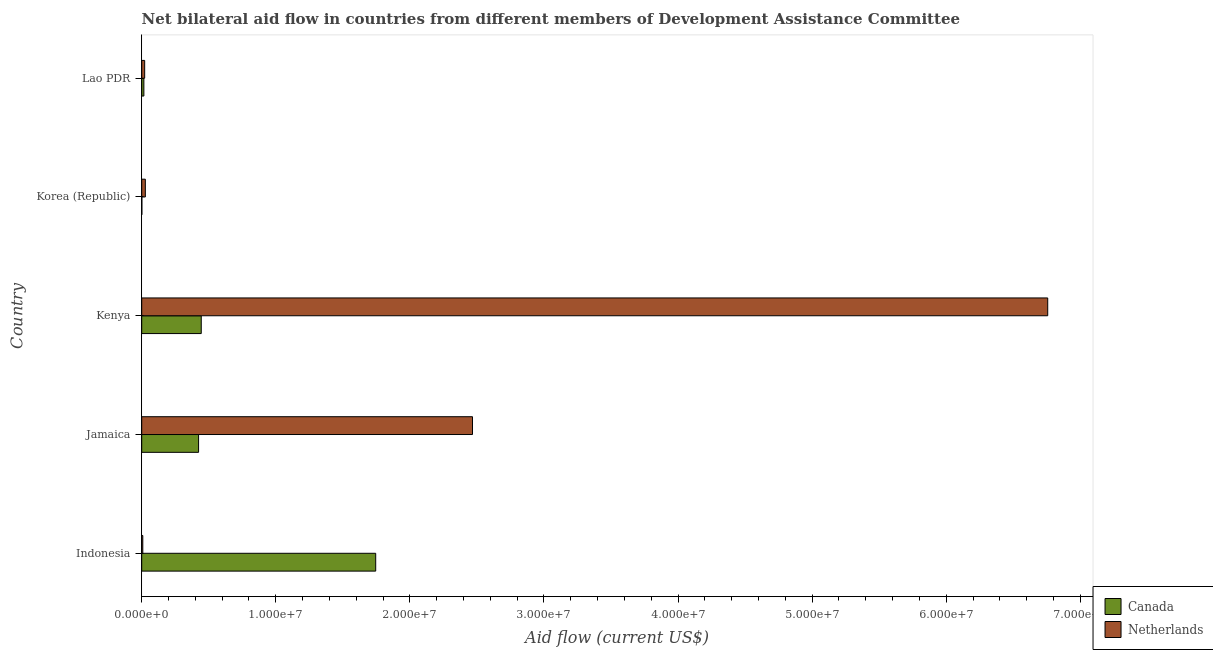How many bars are there on the 1st tick from the bottom?
Offer a terse response. 2. What is the label of the 5th group of bars from the top?
Offer a very short reply. Indonesia. In how many cases, is the number of bars for a given country not equal to the number of legend labels?
Your answer should be very brief. 0. What is the amount of aid given by canada in Kenya?
Offer a very short reply. 4.44e+06. Across all countries, what is the maximum amount of aid given by netherlands?
Keep it short and to the point. 6.76e+07. Across all countries, what is the minimum amount of aid given by canada?
Give a very brief answer. 10000. What is the total amount of aid given by netherlands in the graph?
Make the answer very short. 9.28e+07. What is the difference between the amount of aid given by netherlands in Jamaica and that in Lao PDR?
Give a very brief answer. 2.44e+07. What is the difference between the amount of aid given by netherlands in Kenya and the amount of aid given by canada in Indonesia?
Provide a succinct answer. 5.01e+07. What is the average amount of aid given by canada per country?
Keep it short and to the point. 5.26e+06. What is the difference between the amount of aid given by canada and amount of aid given by netherlands in Korea (Republic)?
Provide a succinct answer. -2.60e+05. What is the ratio of the amount of aid given by canada in Jamaica to that in Kenya?
Make the answer very short. 0.95. Is the amount of aid given by netherlands in Kenya less than that in Lao PDR?
Give a very brief answer. No. Is the difference between the amount of aid given by netherlands in Kenya and Korea (Republic) greater than the difference between the amount of aid given by canada in Kenya and Korea (Republic)?
Offer a terse response. Yes. What is the difference between the highest and the second highest amount of aid given by netherlands?
Ensure brevity in your answer.  4.29e+07. What is the difference between the highest and the lowest amount of aid given by netherlands?
Keep it short and to the point. 6.75e+07. Is the sum of the amount of aid given by netherlands in Indonesia and Lao PDR greater than the maximum amount of aid given by canada across all countries?
Keep it short and to the point. No. What does the 2nd bar from the top in Jamaica represents?
Offer a terse response. Canada. What does the 2nd bar from the bottom in Kenya represents?
Make the answer very short. Netherlands. How many bars are there?
Your response must be concise. 10. Are all the bars in the graph horizontal?
Offer a terse response. Yes. What is the difference between two consecutive major ticks on the X-axis?
Keep it short and to the point. 1.00e+07. Are the values on the major ticks of X-axis written in scientific E-notation?
Offer a terse response. Yes. Does the graph contain grids?
Offer a terse response. No. Where does the legend appear in the graph?
Keep it short and to the point. Bottom right. How many legend labels are there?
Keep it short and to the point. 2. How are the legend labels stacked?
Keep it short and to the point. Vertical. What is the title of the graph?
Make the answer very short. Net bilateral aid flow in countries from different members of Development Assistance Committee. Does "International Tourists" appear as one of the legend labels in the graph?
Your response must be concise. No. What is the label or title of the X-axis?
Your response must be concise. Aid flow (current US$). What is the Aid flow (current US$) in Canada in Indonesia?
Give a very brief answer. 1.74e+07. What is the Aid flow (current US$) in Netherlands in Indonesia?
Ensure brevity in your answer.  8.00e+04. What is the Aid flow (current US$) in Canada in Jamaica?
Ensure brevity in your answer.  4.24e+06. What is the Aid flow (current US$) in Netherlands in Jamaica?
Give a very brief answer. 2.47e+07. What is the Aid flow (current US$) in Canada in Kenya?
Offer a very short reply. 4.44e+06. What is the Aid flow (current US$) of Netherlands in Kenya?
Offer a terse response. 6.76e+07. What is the Aid flow (current US$) in Canada in Lao PDR?
Make the answer very short. 1.60e+05. Across all countries, what is the maximum Aid flow (current US$) in Canada?
Your answer should be compact. 1.74e+07. Across all countries, what is the maximum Aid flow (current US$) in Netherlands?
Provide a short and direct response. 6.76e+07. What is the total Aid flow (current US$) of Canada in the graph?
Your response must be concise. 2.63e+07. What is the total Aid flow (current US$) in Netherlands in the graph?
Offer a very short reply. 9.28e+07. What is the difference between the Aid flow (current US$) in Canada in Indonesia and that in Jamaica?
Ensure brevity in your answer.  1.32e+07. What is the difference between the Aid flow (current US$) in Netherlands in Indonesia and that in Jamaica?
Give a very brief answer. -2.46e+07. What is the difference between the Aid flow (current US$) of Canada in Indonesia and that in Kenya?
Make the answer very short. 1.30e+07. What is the difference between the Aid flow (current US$) of Netherlands in Indonesia and that in Kenya?
Offer a terse response. -6.75e+07. What is the difference between the Aid flow (current US$) in Canada in Indonesia and that in Korea (Republic)?
Provide a succinct answer. 1.74e+07. What is the difference between the Aid flow (current US$) of Netherlands in Indonesia and that in Korea (Republic)?
Your answer should be very brief. -1.90e+05. What is the difference between the Aid flow (current US$) in Canada in Indonesia and that in Lao PDR?
Ensure brevity in your answer.  1.73e+07. What is the difference between the Aid flow (current US$) of Netherlands in Indonesia and that in Lao PDR?
Ensure brevity in your answer.  -1.40e+05. What is the difference between the Aid flow (current US$) of Netherlands in Jamaica and that in Kenya?
Your answer should be very brief. -4.29e+07. What is the difference between the Aid flow (current US$) of Canada in Jamaica and that in Korea (Republic)?
Offer a very short reply. 4.23e+06. What is the difference between the Aid flow (current US$) in Netherlands in Jamaica and that in Korea (Republic)?
Your answer should be very brief. 2.44e+07. What is the difference between the Aid flow (current US$) of Canada in Jamaica and that in Lao PDR?
Your response must be concise. 4.08e+06. What is the difference between the Aid flow (current US$) of Netherlands in Jamaica and that in Lao PDR?
Make the answer very short. 2.44e+07. What is the difference between the Aid flow (current US$) in Canada in Kenya and that in Korea (Republic)?
Offer a terse response. 4.43e+06. What is the difference between the Aid flow (current US$) in Netherlands in Kenya and that in Korea (Republic)?
Your response must be concise. 6.73e+07. What is the difference between the Aid flow (current US$) in Canada in Kenya and that in Lao PDR?
Offer a terse response. 4.28e+06. What is the difference between the Aid flow (current US$) of Netherlands in Kenya and that in Lao PDR?
Offer a terse response. 6.74e+07. What is the difference between the Aid flow (current US$) of Canada in Korea (Republic) and that in Lao PDR?
Your answer should be very brief. -1.50e+05. What is the difference between the Aid flow (current US$) in Canada in Indonesia and the Aid flow (current US$) in Netherlands in Jamaica?
Provide a succinct answer. -7.22e+06. What is the difference between the Aid flow (current US$) in Canada in Indonesia and the Aid flow (current US$) in Netherlands in Kenya?
Provide a short and direct response. -5.01e+07. What is the difference between the Aid flow (current US$) of Canada in Indonesia and the Aid flow (current US$) of Netherlands in Korea (Republic)?
Provide a succinct answer. 1.72e+07. What is the difference between the Aid flow (current US$) of Canada in Indonesia and the Aid flow (current US$) of Netherlands in Lao PDR?
Ensure brevity in your answer.  1.72e+07. What is the difference between the Aid flow (current US$) of Canada in Jamaica and the Aid flow (current US$) of Netherlands in Kenya?
Provide a succinct answer. -6.33e+07. What is the difference between the Aid flow (current US$) in Canada in Jamaica and the Aid flow (current US$) in Netherlands in Korea (Republic)?
Provide a succinct answer. 3.97e+06. What is the difference between the Aid flow (current US$) of Canada in Jamaica and the Aid flow (current US$) of Netherlands in Lao PDR?
Your response must be concise. 4.02e+06. What is the difference between the Aid flow (current US$) in Canada in Kenya and the Aid flow (current US$) in Netherlands in Korea (Republic)?
Offer a terse response. 4.17e+06. What is the difference between the Aid flow (current US$) in Canada in Kenya and the Aid flow (current US$) in Netherlands in Lao PDR?
Keep it short and to the point. 4.22e+06. What is the difference between the Aid flow (current US$) of Canada in Korea (Republic) and the Aid flow (current US$) of Netherlands in Lao PDR?
Provide a short and direct response. -2.10e+05. What is the average Aid flow (current US$) in Canada per country?
Make the answer very short. 5.26e+06. What is the average Aid flow (current US$) of Netherlands per country?
Ensure brevity in your answer.  1.86e+07. What is the difference between the Aid flow (current US$) in Canada and Aid flow (current US$) in Netherlands in Indonesia?
Your response must be concise. 1.74e+07. What is the difference between the Aid flow (current US$) in Canada and Aid flow (current US$) in Netherlands in Jamaica?
Offer a very short reply. -2.04e+07. What is the difference between the Aid flow (current US$) of Canada and Aid flow (current US$) of Netherlands in Kenya?
Keep it short and to the point. -6.31e+07. What is the difference between the Aid flow (current US$) in Canada and Aid flow (current US$) in Netherlands in Korea (Republic)?
Ensure brevity in your answer.  -2.60e+05. What is the ratio of the Aid flow (current US$) in Canada in Indonesia to that in Jamaica?
Offer a terse response. 4.12. What is the ratio of the Aid flow (current US$) in Netherlands in Indonesia to that in Jamaica?
Offer a very short reply. 0. What is the ratio of the Aid flow (current US$) in Canada in Indonesia to that in Kenya?
Offer a terse response. 3.93. What is the ratio of the Aid flow (current US$) in Netherlands in Indonesia to that in Kenya?
Provide a succinct answer. 0. What is the ratio of the Aid flow (current US$) of Canada in Indonesia to that in Korea (Republic)?
Provide a short and direct response. 1745. What is the ratio of the Aid flow (current US$) of Netherlands in Indonesia to that in Korea (Republic)?
Keep it short and to the point. 0.3. What is the ratio of the Aid flow (current US$) in Canada in Indonesia to that in Lao PDR?
Make the answer very short. 109.06. What is the ratio of the Aid flow (current US$) in Netherlands in Indonesia to that in Lao PDR?
Your response must be concise. 0.36. What is the ratio of the Aid flow (current US$) of Canada in Jamaica to that in Kenya?
Your answer should be compact. 0.95. What is the ratio of the Aid flow (current US$) in Netherlands in Jamaica to that in Kenya?
Ensure brevity in your answer.  0.37. What is the ratio of the Aid flow (current US$) in Canada in Jamaica to that in Korea (Republic)?
Provide a short and direct response. 424. What is the ratio of the Aid flow (current US$) in Netherlands in Jamaica to that in Korea (Republic)?
Your answer should be very brief. 91.37. What is the ratio of the Aid flow (current US$) of Netherlands in Jamaica to that in Lao PDR?
Provide a short and direct response. 112.14. What is the ratio of the Aid flow (current US$) in Canada in Kenya to that in Korea (Republic)?
Give a very brief answer. 444. What is the ratio of the Aid flow (current US$) in Netherlands in Kenya to that in Korea (Republic)?
Your response must be concise. 250.26. What is the ratio of the Aid flow (current US$) of Canada in Kenya to that in Lao PDR?
Provide a short and direct response. 27.75. What is the ratio of the Aid flow (current US$) in Netherlands in Kenya to that in Lao PDR?
Provide a succinct answer. 307.14. What is the ratio of the Aid flow (current US$) of Canada in Korea (Republic) to that in Lao PDR?
Your answer should be very brief. 0.06. What is the ratio of the Aid flow (current US$) in Netherlands in Korea (Republic) to that in Lao PDR?
Offer a terse response. 1.23. What is the difference between the highest and the second highest Aid flow (current US$) in Canada?
Make the answer very short. 1.30e+07. What is the difference between the highest and the second highest Aid flow (current US$) of Netherlands?
Keep it short and to the point. 4.29e+07. What is the difference between the highest and the lowest Aid flow (current US$) in Canada?
Offer a very short reply. 1.74e+07. What is the difference between the highest and the lowest Aid flow (current US$) in Netherlands?
Make the answer very short. 6.75e+07. 